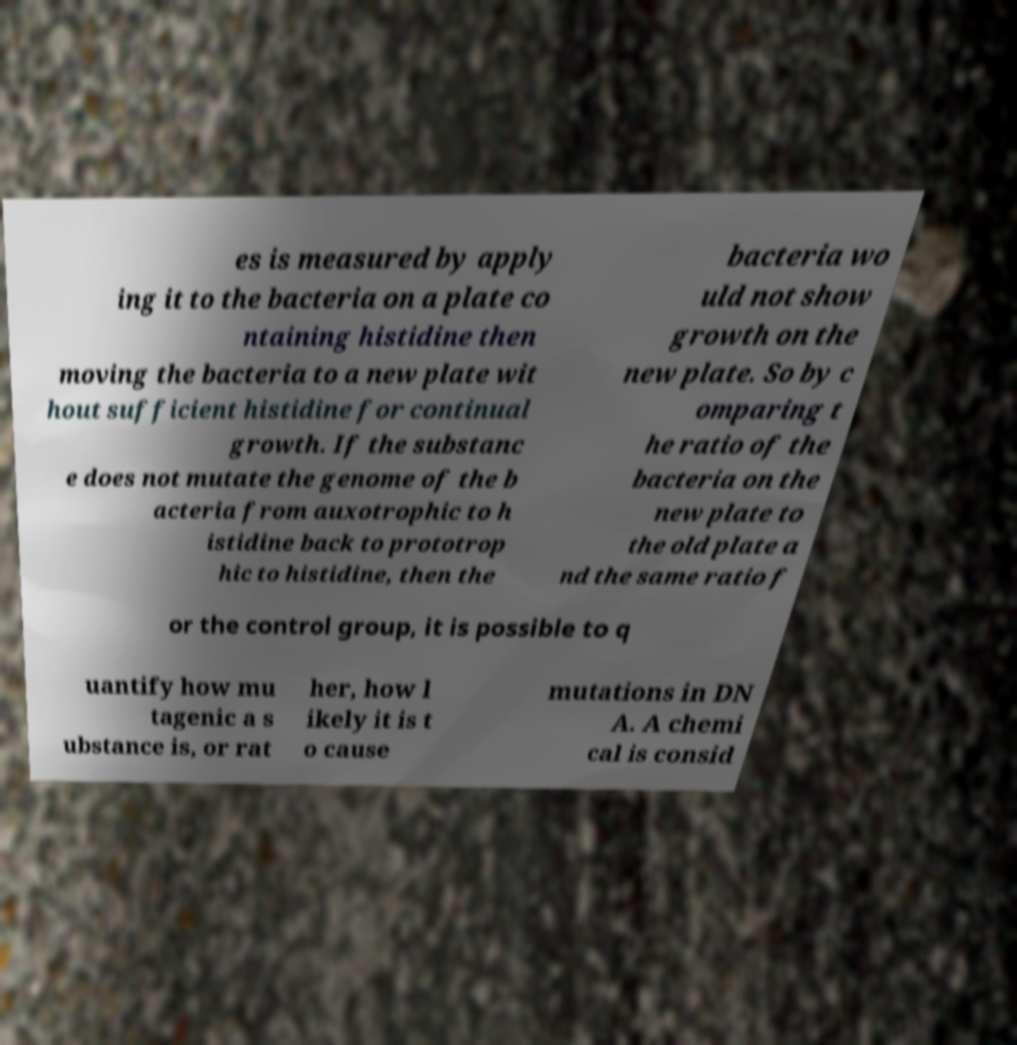Please read and relay the text visible in this image. What does it say? es is measured by apply ing it to the bacteria on a plate co ntaining histidine then moving the bacteria to a new plate wit hout sufficient histidine for continual growth. If the substanc e does not mutate the genome of the b acteria from auxotrophic to h istidine back to prototrop hic to histidine, then the bacteria wo uld not show growth on the new plate. So by c omparing t he ratio of the bacteria on the new plate to the old plate a nd the same ratio f or the control group, it is possible to q uantify how mu tagenic a s ubstance is, or rat her, how l ikely it is t o cause mutations in DN A. A chemi cal is consid 